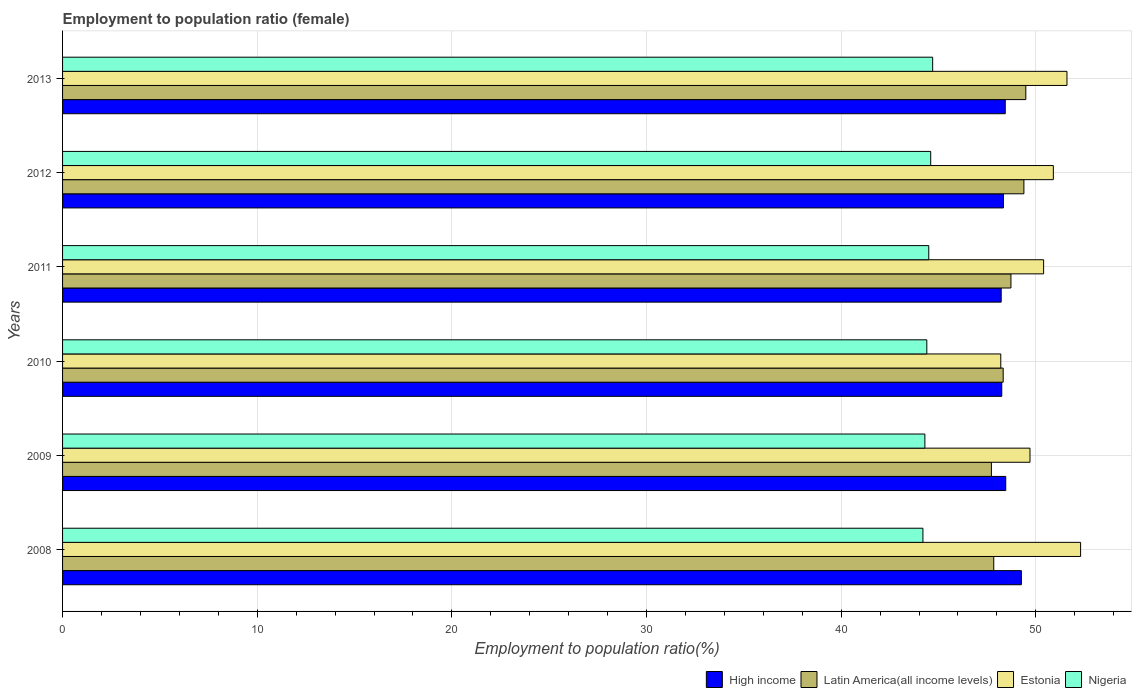How many different coloured bars are there?
Provide a succinct answer. 4. How many groups of bars are there?
Make the answer very short. 6. Are the number of bars per tick equal to the number of legend labels?
Give a very brief answer. Yes. Are the number of bars on each tick of the Y-axis equal?
Give a very brief answer. Yes. How many bars are there on the 3rd tick from the top?
Keep it short and to the point. 4. What is the label of the 2nd group of bars from the top?
Your response must be concise. 2012. What is the employment to population ratio in Latin America(all income levels) in 2008?
Your response must be concise. 47.84. Across all years, what is the maximum employment to population ratio in High income?
Your response must be concise. 49.26. Across all years, what is the minimum employment to population ratio in Latin America(all income levels)?
Provide a succinct answer. 47.72. In which year was the employment to population ratio in High income minimum?
Your response must be concise. 2011. What is the total employment to population ratio in Estonia in the graph?
Make the answer very short. 303.1. What is the difference between the employment to population ratio in High income in 2009 and that in 2012?
Ensure brevity in your answer.  0.12. What is the difference between the employment to population ratio in Nigeria in 2011 and the employment to population ratio in Estonia in 2008?
Ensure brevity in your answer.  -7.8. What is the average employment to population ratio in Nigeria per year?
Offer a terse response. 44.45. In the year 2009, what is the difference between the employment to population ratio in High income and employment to population ratio in Estonia?
Your response must be concise. -1.24. In how many years, is the employment to population ratio in Nigeria greater than 50 %?
Keep it short and to the point. 0. What is the ratio of the employment to population ratio in Estonia in 2008 to that in 2013?
Give a very brief answer. 1.01. Is the employment to population ratio in High income in 2011 less than that in 2013?
Ensure brevity in your answer.  Yes. Is the difference between the employment to population ratio in High income in 2010 and 2013 greater than the difference between the employment to population ratio in Estonia in 2010 and 2013?
Provide a short and direct response. Yes. What is the difference between the highest and the second highest employment to population ratio in High income?
Your response must be concise. 0.8. What is the difference between the highest and the lowest employment to population ratio in Latin America(all income levels)?
Your answer should be compact. 1.77. In how many years, is the employment to population ratio in High income greater than the average employment to population ratio in High income taken over all years?
Offer a very short reply. 1. Is the sum of the employment to population ratio in Latin America(all income levels) in 2009 and 2011 greater than the maximum employment to population ratio in Nigeria across all years?
Make the answer very short. Yes. Is it the case that in every year, the sum of the employment to population ratio in Latin America(all income levels) and employment to population ratio in Nigeria is greater than the sum of employment to population ratio in High income and employment to population ratio in Estonia?
Your answer should be compact. No. What does the 3rd bar from the top in 2010 represents?
Your answer should be compact. Latin America(all income levels). What does the 3rd bar from the bottom in 2009 represents?
Offer a terse response. Estonia. Is it the case that in every year, the sum of the employment to population ratio in Latin America(all income levels) and employment to population ratio in Estonia is greater than the employment to population ratio in High income?
Offer a very short reply. Yes. How many bars are there?
Provide a short and direct response. 24. How many years are there in the graph?
Offer a very short reply. 6. Are the values on the major ticks of X-axis written in scientific E-notation?
Offer a very short reply. No. What is the title of the graph?
Your answer should be compact. Employment to population ratio (female). Does "High income" appear as one of the legend labels in the graph?
Provide a short and direct response. Yes. What is the label or title of the X-axis?
Keep it short and to the point. Employment to population ratio(%). What is the label or title of the Y-axis?
Keep it short and to the point. Years. What is the Employment to population ratio(%) of High income in 2008?
Provide a short and direct response. 49.26. What is the Employment to population ratio(%) in Latin America(all income levels) in 2008?
Your answer should be very brief. 47.84. What is the Employment to population ratio(%) in Estonia in 2008?
Offer a very short reply. 52.3. What is the Employment to population ratio(%) in Nigeria in 2008?
Offer a very short reply. 44.2. What is the Employment to population ratio(%) of High income in 2009?
Offer a very short reply. 48.46. What is the Employment to population ratio(%) in Latin America(all income levels) in 2009?
Your answer should be compact. 47.72. What is the Employment to population ratio(%) of Estonia in 2009?
Your answer should be compact. 49.7. What is the Employment to population ratio(%) of Nigeria in 2009?
Provide a succinct answer. 44.3. What is the Employment to population ratio(%) in High income in 2010?
Keep it short and to the point. 48.25. What is the Employment to population ratio(%) in Latin America(all income levels) in 2010?
Provide a short and direct response. 48.32. What is the Employment to population ratio(%) of Estonia in 2010?
Provide a short and direct response. 48.2. What is the Employment to population ratio(%) in Nigeria in 2010?
Your answer should be very brief. 44.4. What is the Employment to population ratio(%) of High income in 2011?
Offer a terse response. 48.22. What is the Employment to population ratio(%) in Latin America(all income levels) in 2011?
Your answer should be very brief. 48.72. What is the Employment to population ratio(%) in Estonia in 2011?
Offer a very short reply. 50.4. What is the Employment to population ratio(%) in Nigeria in 2011?
Your answer should be very brief. 44.5. What is the Employment to population ratio(%) of High income in 2012?
Provide a short and direct response. 48.34. What is the Employment to population ratio(%) in Latin America(all income levels) in 2012?
Offer a terse response. 49.39. What is the Employment to population ratio(%) in Estonia in 2012?
Make the answer very short. 50.9. What is the Employment to population ratio(%) of Nigeria in 2012?
Give a very brief answer. 44.6. What is the Employment to population ratio(%) of High income in 2013?
Offer a very short reply. 48.43. What is the Employment to population ratio(%) of Latin America(all income levels) in 2013?
Offer a very short reply. 49.49. What is the Employment to population ratio(%) in Estonia in 2013?
Provide a succinct answer. 51.6. What is the Employment to population ratio(%) of Nigeria in 2013?
Ensure brevity in your answer.  44.7. Across all years, what is the maximum Employment to population ratio(%) in High income?
Keep it short and to the point. 49.26. Across all years, what is the maximum Employment to population ratio(%) of Latin America(all income levels)?
Ensure brevity in your answer.  49.49. Across all years, what is the maximum Employment to population ratio(%) of Estonia?
Offer a very short reply. 52.3. Across all years, what is the maximum Employment to population ratio(%) of Nigeria?
Your answer should be very brief. 44.7. Across all years, what is the minimum Employment to population ratio(%) of High income?
Keep it short and to the point. 48.22. Across all years, what is the minimum Employment to population ratio(%) in Latin America(all income levels)?
Give a very brief answer. 47.72. Across all years, what is the minimum Employment to population ratio(%) in Estonia?
Ensure brevity in your answer.  48.2. Across all years, what is the minimum Employment to population ratio(%) in Nigeria?
Your answer should be very brief. 44.2. What is the total Employment to population ratio(%) in High income in the graph?
Your answer should be compact. 290.95. What is the total Employment to population ratio(%) of Latin America(all income levels) in the graph?
Ensure brevity in your answer.  291.48. What is the total Employment to population ratio(%) in Estonia in the graph?
Make the answer very short. 303.1. What is the total Employment to population ratio(%) in Nigeria in the graph?
Your response must be concise. 266.7. What is the difference between the Employment to population ratio(%) in High income in 2008 and that in 2009?
Offer a terse response. 0.8. What is the difference between the Employment to population ratio(%) of Latin America(all income levels) in 2008 and that in 2009?
Offer a very short reply. 0.12. What is the difference between the Employment to population ratio(%) in Estonia in 2008 and that in 2009?
Ensure brevity in your answer.  2.6. What is the difference between the Employment to population ratio(%) in Nigeria in 2008 and that in 2009?
Offer a very short reply. -0.1. What is the difference between the Employment to population ratio(%) of Latin America(all income levels) in 2008 and that in 2010?
Provide a succinct answer. -0.48. What is the difference between the Employment to population ratio(%) of High income in 2008 and that in 2011?
Offer a very short reply. 1.04. What is the difference between the Employment to population ratio(%) in Latin America(all income levels) in 2008 and that in 2011?
Your answer should be very brief. -0.88. What is the difference between the Employment to population ratio(%) in High income in 2008 and that in 2012?
Provide a short and direct response. 0.92. What is the difference between the Employment to population ratio(%) of Latin America(all income levels) in 2008 and that in 2012?
Ensure brevity in your answer.  -1.55. What is the difference between the Employment to population ratio(%) of High income in 2008 and that in 2013?
Your answer should be compact. 0.83. What is the difference between the Employment to population ratio(%) in Latin America(all income levels) in 2008 and that in 2013?
Provide a short and direct response. -1.65. What is the difference between the Employment to population ratio(%) of High income in 2009 and that in 2010?
Provide a succinct answer. 0.2. What is the difference between the Employment to population ratio(%) of Latin America(all income levels) in 2009 and that in 2010?
Give a very brief answer. -0.61. What is the difference between the Employment to population ratio(%) of Estonia in 2009 and that in 2010?
Your response must be concise. 1.5. What is the difference between the Employment to population ratio(%) of Nigeria in 2009 and that in 2010?
Your answer should be very brief. -0.1. What is the difference between the Employment to population ratio(%) of High income in 2009 and that in 2011?
Give a very brief answer. 0.23. What is the difference between the Employment to population ratio(%) of Latin America(all income levels) in 2009 and that in 2011?
Give a very brief answer. -1. What is the difference between the Employment to population ratio(%) in Estonia in 2009 and that in 2011?
Ensure brevity in your answer.  -0.7. What is the difference between the Employment to population ratio(%) in High income in 2009 and that in 2012?
Offer a terse response. 0.12. What is the difference between the Employment to population ratio(%) of Latin America(all income levels) in 2009 and that in 2012?
Make the answer very short. -1.67. What is the difference between the Employment to population ratio(%) in Nigeria in 2009 and that in 2012?
Offer a very short reply. -0.3. What is the difference between the Employment to population ratio(%) of High income in 2009 and that in 2013?
Your answer should be compact. 0.03. What is the difference between the Employment to population ratio(%) of Latin America(all income levels) in 2009 and that in 2013?
Provide a succinct answer. -1.77. What is the difference between the Employment to population ratio(%) in Estonia in 2009 and that in 2013?
Provide a succinct answer. -1.9. What is the difference between the Employment to population ratio(%) in High income in 2010 and that in 2011?
Offer a very short reply. 0.03. What is the difference between the Employment to population ratio(%) in Latin America(all income levels) in 2010 and that in 2011?
Provide a short and direct response. -0.4. What is the difference between the Employment to population ratio(%) in Nigeria in 2010 and that in 2011?
Your answer should be very brief. -0.1. What is the difference between the Employment to population ratio(%) in High income in 2010 and that in 2012?
Your response must be concise. -0.09. What is the difference between the Employment to population ratio(%) in Latin America(all income levels) in 2010 and that in 2012?
Your response must be concise. -1.06. What is the difference between the Employment to population ratio(%) in Estonia in 2010 and that in 2012?
Your answer should be very brief. -2.7. What is the difference between the Employment to population ratio(%) of High income in 2010 and that in 2013?
Your answer should be compact. -0.18. What is the difference between the Employment to population ratio(%) of Latin America(all income levels) in 2010 and that in 2013?
Keep it short and to the point. -1.16. What is the difference between the Employment to population ratio(%) of Estonia in 2010 and that in 2013?
Provide a short and direct response. -3.4. What is the difference between the Employment to population ratio(%) of High income in 2011 and that in 2012?
Provide a succinct answer. -0.12. What is the difference between the Employment to population ratio(%) in Latin America(all income levels) in 2011 and that in 2012?
Make the answer very short. -0.67. What is the difference between the Employment to population ratio(%) in Estonia in 2011 and that in 2012?
Offer a very short reply. -0.5. What is the difference between the Employment to population ratio(%) in Nigeria in 2011 and that in 2012?
Provide a short and direct response. -0.1. What is the difference between the Employment to population ratio(%) of High income in 2011 and that in 2013?
Ensure brevity in your answer.  -0.21. What is the difference between the Employment to population ratio(%) in Latin America(all income levels) in 2011 and that in 2013?
Offer a very short reply. -0.76. What is the difference between the Employment to population ratio(%) in Estonia in 2011 and that in 2013?
Give a very brief answer. -1.2. What is the difference between the Employment to population ratio(%) in High income in 2012 and that in 2013?
Your answer should be very brief. -0.09. What is the difference between the Employment to population ratio(%) in Latin America(all income levels) in 2012 and that in 2013?
Your response must be concise. -0.1. What is the difference between the Employment to population ratio(%) in Estonia in 2012 and that in 2013?
Keep it short and to the point. -0.7. What is the difference between the Employment to population ratio(%) of High income in 2008 and the Employment to population ratio(%) of Latin America(all income levels) in 2009?
Keep it short and to the point. 1.54. What is the difference between the Employment to population ratio(%) in High income in 2008 and the Employment to population ratio(%) in Estonia in 2009?
Keep it short and to the point. -0.44. What is the difference between the Employment to population ratio(%) of High income in 2008 and the Employment to population ratio(%) of Nigeria in 2009?
Provide a short and direct response. 4.96. What is the difference between the Employment to population ratio(%) in Latin America(all income levels) in 2008 and the Employment to population ratio(%) in Estonia in 2009?
Make the answer very short. -1.86. What is the difference between the Employment to population ratio(%) of Latin America(all income levels) in 2008 and the Employment to population ratio(%) of Nigeria in 2009?
Offer a terse response. 3.54. What is the difference between the Employment to population ratio(%) of High income in 2008 and the Employment to population ratio(%) of Latin America(all income levels) in 2010?
Provide a succinct answer. 0.93. What is the difference between the Employment to population ratio(%) in High income in 2008 and the Employment to population ratio(%) in Estonia in 2010?
Provide a short and direct response. 1.06. What is the difference between the Employment to population ratio(%) of High income in 2008 and the Employment to population ratio(%) of Nigeria in 2010?
Your answer should be very brief. 4.86. What is the difference between the Employment to population ratio(%) of Latin America(all income levels) in 2008 and the Employment to population ratio(%) of Estonia in 2010?
Provide a succinct answer. -0.36. What is the difference between the Employment to population ratio(%) in Latin America(all income levels) in 2008 and the Employment to population ratio(%) in Nigeria in 2010?
Your response must be concise. 3.44. What is the difference between the Employment to population ratio(%) in Estonia in 2008 and the Employment to population ratio(%) in Nigeria in 2010?
Provide a short and direct response. 7.9. What is the difference between the Employment to population ratio(%) in High income in 2008 and the Employment to population ratio(%) in Latin America(all income levels) in 2011?
Keep it short and to the point. 0.54. What is the difference between the Employment to population ratio(%) of High income in 2008 and the Employment to population ratio(%) of Estonia in 2011?
Give a very brief answer. -1.14. What is the difference between the Employment to population ratio(%) of High income in 2008 and the Employment to population ratio(%) of Nigeria in 2011?
Your response must be concise. 4.76. What is the difference between the Employment to population ratio(%) in Latin America(all income levels) in 2008 and the Employment to population ratio(%) in Estonia in 2011?
Make the answer very short. -2.56. What is the difference between the Employment to population ratio(%) in Latin America(all income levels) in 2008 and the Employment to population ratio(%) in Nigeria in 2011?
Make the answer very short. 3.34. What is the difference between the Employment to population ratio(%) of High income in 2008 and the Employment to population ratio(%) of Latin America(all income levels) in 2012?
Ensure brevity in your answer.  -0.13. What is the difference between the Employment to population ratio(%) of High income in 2008 and the Employment to population ratio(%) of Estonia in 2012?
Ensure brevity in your answer.  -1.64. What is the difference between the Employment to population ratio(%) of High income in 2008 and the Employment to population ratio(%) of Nigeria in 2012?
Offer a terse response. 4.66. What is the difference between the Employment to population ratio(%) in Latin America(all income levels) in 2008 and the Employment to population ratio(%) in Estonia in 2012?
Keep it short and to the point. -3.06. What is the difference between the Employment to population ratio(%) of Latin America(all income levels) in 2008 and the Employment to population ratio(%) of Nigeria in 2012?
Offer a terse response. 3.24. What is the difference between the Employment to population ratio(%) in Estonia in 2008 and the Employment to population ratio(%) in Nigeria in 2012?
Ensure brevity in your answer.  7.7. What is the difference between the Employment to population ratio(%) in High income in 2008 and the Employment to population ratio(%) in Latin America(all income levels) in 2013?
Give a very brief answer. -0.23. What is the difference between the Employment to population ratio(%) in High income in 2008 and the Employment to population ratio(%) in Estonia in 2013?
Provide a succinct answer. -2.34. What is the difference between the Employment to population ratio(%) of High income in 2008 and the Employment to population ratio(%) of Nigeria in 2013?
Keep it short and to the point. 4.56. What is the difference between the Employment to population ratio(%) in Latin America(all income levels) in 2008 and the Employment to population ratio(%) in Estonia in 2013?
Ensure brevity in your answer.  -3.76. What is the difference between the Employment to population ratio(%) of Latin America(all income levels) in 2008 and the Employment to population ratio(%) of Nigeria in 2013?
Give a very brief answer. 3.14. What is the difference between the Employment to population ratio(%) of Estonia in 2008 and the Employment to population ratio(%) of Nigeria in 2013?
Keep it short and to the point. 7.6. What is the difference between the Employment to population ratio(%) in High income in 2009 and the Employment to population ratio(%) in Latin America(all income levels) in 2010?
Your response must be concise. 0.13. What is the difference between the Employment to population ratio(%) in High income in 2009 and the Employment to population ratio(%) in Estonia in 2010?
Your response must be concise. 0.26. What is the difference between the Employment to population ratio(%) of High income in 2009 and the Employment to population ratio(%) of Nigeria in 2010?
Offer a very short reply. 4.06. What is the difference between the Employment to population ratio(%) in Latin America(all income levels) in 2009 and the Employment to population ratio(%) in Estonia in 2010?
Provide a short and direct response. -0.48. What is the difference between the Employment to population ratio(%) in Latin America(all income levels) in 2009 and the Employment to population ratio(%) in Nigeria in 2010?
Ensure brevity in your answer.  3.32. What is the difference between the Employment to population ratio(%) in Estonia in 2009 and the Employment to population ratio(%) in Nigeria in 2010?
Your answer should be compact. 5.3. What is the difference between the Employment to population ratio(%) in High income in 2009 and the Employment to population ratio(%) in Latin America(all income levels) in 2011?
Ensure brevity in your answer.  -0.27. What is the difference between the Employment to population ratio(%) of High income in 2009 and the Employment to population ratio(%) of Estonia in 2011?
Your answer should be very brief. -1.94. What is the difference between the Employment to population ratio(%) in High income in 2009 and the Employment to population ratio(%) in Nigeria in 2011?
Provide a short and direct response. 3.96. What is the difference between the Employment to population ratio(%) of Latin America(all income levels) in 2009 and the Employment to population ratio(%) of Estonia in 2011?
Your answer should be compact. -2.68. What is the difference between the Employment to population ratio(%) of Latin America(all income levels) in 2009 and the Employment to population ratio(%) of Nigeria in 2011?
Your response must be concise. 3.22. What is the difference between the Employment to population ratio(%) in Estonia in 2009 and the Employment to population ratio(%) in Nigeria in 2011?
Your response must be concise. 5.2. What is the difference between the Employment to population ratio(%) of High income in 2009 and the Employment to population ratio(%) of Latin America(all income levels) in 2012?
Offer a terse response. -0.93. What is the difference between the Employment to population ratio(%) in High income in 2009 and the Employment to population ratio(%) in Estonia in 2012?
Offer a very short reply. -2.44. What is the difference between the Employment to population ratio(%) in High income in 2009 and the Employment to population ratio(%) in Nigeria in 2012?
Your response must be concise. 3.86. What is the difference between the Employment to population ratio(%) in Latin America(all income levels) in 2009 and the Employment to population ratio(%) in Estonia in 2012?
Keep it short and to the point. -3.18. What is the difference between the Employment to population ratio(%) of Latin America(all income levels) in 2009 and the Employment to population ratio(%) of Nigeria in 2012?
Your answer should be compact. 3.12. What is the difference between the Employment to population ratio(%) in Estonia in 2009 and the Employment to population ratio(%) in Nigeria in 2012?
Offer a very short reply. 5.1. What is the difference between the Employment to population ratio(%) of High income in 2009 and the Employment to population ratio(%) of Latin America(all income levels) in 2013?
Your answer should be compact. -1.03. What is the difference between the Employment to population ratio(%) of High income in 2009 and the Employment to population ratio(%) of Estonia in 2013?
Your answer should be very brief. -3.14. What is the difference between the Employment to population ratio(%) in High income in 2009 and the Employment to population ratio(%) in Nigeria in 2013?
Your response must be concise. 3.76. What is the difference between the Employment to population ratio(%) in Latin America(all income levels) in 2009 and the Employment to population ratio(%) in Estonia in 2013?
Your answer should be very brief. -3.88. What is the difference between the Employment to population ratio(%) in Latin America(all income levels) in 2009 and the Employment to population ratio(%) in Nigeria in 2013?
Provide a succinct answer. 3.02. What is the difference between the Employment to population ratio(%) of Estonia in 2009 and the Employment to population ratio(%) of Nigeria in 2013?
Your response must be concise. 5. What is the difference between the Employment to population ratio(%) in High income in 2010 and the Employment to population ratio(%) in Latin America(all income levels) in 2011?
Your answer should be very brief. -0.47. What is the difference between the Employment to population ratio(%) of High income in 2010 and the Employment to population ratio(%) of Estonia in 2011?
Your answer should be very brief. -2.15. What is the difference between the Employment to population ratio(%) of High income in 2010 and the Employment to population ratio(%) of Nigeria in 2011?
Make the answer very short. 3.75. What is the difference between the Employment to population ratio(%) in Latin America(all income levels) in 2010 and the Employment to population ratio(%) in Estonia in 2011?
Offer a terse response. -2.08. What is the difference between the Employment to population ratio(%) of Latin America(all income levels) in 2010 and the Employment to population ratio(%) of Nigeria in 2011?
Provide a succinct answer. 3.82. What is the difference between the Employment to population ratio(%) of High income in 2010 and the Employment to population ratio(%) of Latin America(all income levels) in 2012?
Make the answer very short. -1.14. What is the difference between the Employment to population ratio(%) of High income in 2010 and the Employment to population ratio(%) of Estonia in 2012?
Provide a short and direct response. -2.65. What is the difference between the Employment to population ratio(%) of High income in 2010 and the Employment to population ratio(%) of Nigeria in 2012?
Your answer should be compact. 3.65. What is the difference between the Employment to population ratio(%) in Latin America(all income levels) in 2010 and the Employment to population ratio(%) in Estonia in 2012?
Keep it short and to the point. -2.58. What is the difference between the Employment to population ratio(%) in Latin America(all income levels) in 2010 and the Employment to population ratio(%) in Nigeria in 2012?
Your answer should be very brief. 3.72. What is the difference between the Employment to population ratio(%) of Estonia in 2010 and the Employment to population ratio(%) of Nigeria in 2012?
Your answer should be compact. 3.6. What is the difference between the Employment to population ratio(%) in High income in 2010 and the Employment to population ratio(%) in Latin America(all income levels) in 2013?
Your response must be concise. -1.24. What is the difference between the Employment to population ratio(%) of High income in 2010 and the Employment to population ratio(%) of Estonia in 2013?
Your answer should be very brief. -3.35. What is the difference between the Employment to population ratio(%) in High income in 2010 and the Employment to population ratio(%) in Nigeria in 2013?
Offer a very short reply. 3.55. What is the difference between the Employment to population ratio(%) of Latin America(all income levels) in 2010 and the Employment to population ratio(%) of Estonia in 2013?
Keep it short and to the point. -3.28. What is the difference between the Employment to population ratio(%) of Latin America(all income levels) in 2010 and the Employment to population ratio(%) of Nigeria in 2013?
Make the answer very short. 3.62. What is the difference between the Employment to population ratio(%) of Estonia in 2010 and the Employment to population ratio(%) of Nigeria in 2013?
Offer a terse response. 3.5. What is the difference between the Employment to population ratio(%) of High income in 2011 and the Employment to population ratio(%) of Latin America(all income levels) in 2012?
Your answer should be very brief. -1.17. What is the difference between the Employment to population ratio(%) of High income in 2011 and the Employment to population ratio(%) of Estonia in 2012?
Offer a very short reply. -2.68. What is the difference between the Employment to population ratio(%) of High income in 2011 and the Employment to population ratio(%) of Nigeria in 2012?
Your answer should be very brief. 3.62. What is the difference between the Employment to population ratio(%) in Latin America(all income levels) in 2011 and the Employment to population ratio(%) in Estonia in 2012?
Make the answer very short. -2.18. What is the difference between the Employment to population ratio(%) in Latin America(all income levels) in 2011 and the Employment to population ratio(%) in Nigeria in 2012?
Give a very brief answer. 4.12. What is the difference between the Employment to population ratio(%) of High income in 2011 and the Employment to population ratio(%) of Latin America(all income levels) in 2013?
Make the answer very short. -1.27. What is the difference between the Employment to population ratio(%) in High income in 2011 and the Employment to population ratio(%) in Estonia in 2013?
Provide a succinct answer. -3.38. What is the difference between the Employment to population ratio(%) of High income in 2011 and the Employment to population ratio(%) of Nigeria in 2013?
Offer a terse response. 3.52. What is the difference between the Employment to population ratio(%) in Latin America(all income levels) in 2011 and the Employment to population ratio(%) in Estonia in 2013?
Make the answer very short. -2.88. What is the difference between the Employment to population ratio(%) of Latin America(all income levels) in 2011 and the Employment to population ratio(%) of Nigeria in 2013?
Provide a succinct answer. 4.02. What is the difference between the Employment to population ratio(%) of Estonia in 2011 and the Employment to population ratio(%) of Nigeria in 2013?
Your response must be concise. 5.7. What is the difference between the Employment to population ratio(%) of High income in 2012 and the Employment to population ratio(%) of Latin America(all income levels) in 2013?
Ensure brevity in your answer.  -1.15. What is the difference between the Employment to population ratio(%) of High income in 2012 and the Employment to population ratio(%) of Estonia in 2013?
Ensure brevity in your answer.  -3.26. What is the difference between the Employment to population ratio(%) of High income in 2012 and the Employment to population ratio(%) of Nigeria in 2013?
Make the answer very short. 3.64. What is the difference between the Employment to population ratio(%) in Latin America(all income levels) in 2012 and the Employment to population ratio(%) in Estonia in 2013?
Ensure brevity in your answer.  -2.21. What is the difference between the Employment to population ratio(%) of Latin America(all income levels) in 2012 and the Employment to population ratio(%) of Nigeria in 2013?
Keep it short and to the point. 4.69. What is the average Employment to population ratio(%) in High income per year?
Your answer should be very brief. 48.49. What is the average Employment to population ratio(%) in Latin America(all income levels) per year?
Your answer should be very brief. 48.58. What is the average Employment to population ratio(%) in Estonia per year?
Your answer should be very brief. 50.52. What is the average Employment to population ratio(%) in Nigeria per year?
Make the answer very short. 44.45. In the year 2008, what is the difference between the Employment to population ratio(%) in High income and Employment to population ratio(%) in Latin America(all income levels)?
Give a very brief answer. 1.42. In the year 2008, what is the difference between the Employment to population ratio(%) of High income and Employment to population ratio(%) of Estonia?
Offer a very short reply. -3.04. In the year 2008, what is the difference between the Employment to population ratio(%) in High income and Employment to population ratio(%) in Nigeria?
Ensure brevity in your answer.  5.06. In the year 2008, what is the difference between the Employment to population ratio(%) of Latin America(all income levels) and Employment to population ratio(%) of Estonia?
Provide a short and direct response. -4.46. In the year 2008, what is the difference between the Employment to population ratio(%) of Latin America(all income levels) and Employment to population ratio(%) of Nigeria?
Your response must be concise. 3.64. In the year 2009, what is the difference between the Employment to population ratio(%) in High income and Employment to population ratio(%) in Latin America(all income levels)?
Provide a succinct answer. 0.74. In the year 2009, what is the difference between the Employment to population ratio(%) in High income and Employment to population ratio(%) in Estonia?
Give a very brief answer. -1.24. In the year 2009, what is the difference between the Employment to population ratio(%) of High income and Employment to population ratio(%) of Nigeria?
Ensure brevity in your answer.  4.16. In the year 2009, what is the difference between the Employment to population ratio(%) in Latin America(all income levels) and Employment to population ratio(%) in Estonia?
Make the answer very short. -1.98. In the year 2009, what is the difference between the Employment to population ratio(%) of Latin America(all income levels) and Employment to population ratio(%) of Nigeria?
Your response must be concise. 3.42. In the year 2009, what is the difference between the Employment to population ratio(%) in Estonia and Employment to population ratio(%) in Nigeria?
Provide a succinct answer. 5.4. In the year 2010, what is the difference between the Employment to population ratio(%) of High income and Employment to population ratio(%) of Latin America(all income levels)?
Your answer should be very brief. -0.07. In the year 2010, what is the difference between the Employment to population ratio(%) in High income and Employment to population ratio(%) in Estonia?
Make the answer very short. 0.05. In the year 2010, what is the difference between the Employment to population ratio(%) in High income and Employment to population ratio(%) in Nigeria?
Offer a terse response. 3.85. In the year 2010, what is the difference between the Employment to population ratio(%) of Latin America(all income levels) and Employment to population ratio(%) of Estonia?
Give a very brief answer. 0.12. In the year 2010, what is the difference between the Employment to population ratio(%) in Latin America(all income levels) and Employment to population ratio(%) in Nigeria?
Ensure brevity in your answer.  3.92. In the year 2010, what is the difference between the Employment to population ratio(%) in Estonia and Employment to population ratio(%) in Nigeria?
Your answer should be compact. 3.8. In the year 2011, what is the difference between the Employment to population ratio(%) in High income and Employment to population ratio(%) in Latin America(all income levels)?
Your answer should be very brief. -0.5. In the year 2011, what is the difference between the Employment to population ratio(%) of High income and Employment to population ratio(%) of Estonia?
Your answer should be compact. -2.18. In the year 2011, what is the difference between the Employment to population ratio(%) in High income and Employment to population ratio(%) in Nigeria?
Your answer should be compact. 3.72. In the year 2011, what is the difference between the Employment to population ratio(%) in Latin America(all income levels) and Employment to population ratio(%) in Estonia?
Your answer should be compact. -1.68. In the year 2011, what is the difference between the Employment to population ratio(%) of Latin America(all income levels) and Employment to population ratio(%) of Nigeria?
Make the answer very short. 4.22. In the year 2011, what is the difference between the Employment to population ratio(%) of Estonia and Employment to population ratio(%) of Nigeria?
Your answer should be compact. 5.9. In the year 2012, what is the difference between the Employment to population ratio(%) in High income and Employment to population ratio(%) in Latin America(all income levels)?
Your answer should be very brief. -1.05. In the year 2012, what is the difference between the Employment to population ratio(%) of High income and Employment to population ratio(%) of Estonia?
Ensure brevity in your answer.  -2.56. In the year 2012, what is the difference between the Employment to population ratio(%) in High income and Employment to population ratio(%) in Nigeria?
Your answer should be very brief. 3.74. In the year 2012, what is the difference between the Employment to population ratio(%) in Latin America(all income levels) and Employment to population ratio(%) in Estonia?
Provide a short and direct response. -1.51. In the year 2012, what is the difference between the Employment to population ratio(%) of Latin America(all income levels) and Employment to population ratio(%) of Nigeria?
Keep it short and to the point. 4.79. In the year 2012, what is the difference between the Employment to population ratio(%) of Estonia and Employment to population ratio(%) of Nigeria?
Give a very brief answer. 6.3. In the year 2013, what is the difference between the Employment to population ratio(%) of High income and Employment to population ratio(%) of Latin America(all income levels)?
Ensure brevity in your answer.  -1.06. In the year 2013, what is the difference between the Employment to population ratio(%) of High income and Employment to population ratio(%) of Estonia?
Provide a short and direct response. -3.17. In the year 2013, what is the difference between the Employment to population ratio(%) of High income and Employment to population ratio(%) of Nigeria?
Offer a very short reply. 3.73. In the year 2013, what is the difference between the Employment to population ratio(%) of Latin America(all income levels) and Employment to population ratio(%) of Estonia?
Give a very brief answer. -2.11. In the year 2013, what is the difference between the Employment to population ratio(%) in Latin America(all income levels) and Employment to population ratio(%) in Nigeria?
Give a very brief answer. 4.79. What is the ratio of the Employment to population ratio(%) of High income in 2008 to that in 2009?
Your response must be concise. 1.02. What is the ratio of the Employment to population ratio(%) in Latin America(all income levels) in 2008 to that in 2009?
Your answer should be compact. 1. What is the ratio of the Employment to population ratio(%) in Estonia in 2008 to that in 2009?
Your answer should be compact. 1.05. What is the ratio of the Employment to population ratio(%) in High income in 2008 to that in 2010?
Your response must be concise. 1.02. What is the ratio of the Employment to population ratio(%) of Latin America(all income levels) in 2008 to that in 2010?
Your answer should be compact. 0.99. What is the ratio of the Employment to population ratio(%) of Estonia in 2008 to that in 2010?
Provide a succinct answer. 1.09. What is the ratio of the Employment to population ratio(%) of Nigeria in 2008 to that in 2010?
Your response must be concise. 1. What is the ratio of the Employment to population ratio(%) of High income in 2008 to that in 2011?
Provide a short and direct response. 1.02. What is the ratio of the Employment to population ratio(%) in Latin America(all income levels) in 2008 to that in 2011?
Provide a succinct answer. 0.98. What is the ratio of the Employment to population ratio(%) of Estonia in 2008 to that in 2011?
Provide a short and direct response. 1.04. What is the ratio of the Employment to population ratio(%) in High income in 2008 to that in 2012?
Offer a terse response. 1.02. What is the ratio of the Employment to population ratio(%) of Latin America(all income levels) in 2008 to that in 2012?
Your answer should be very brief. 0.97. What is the ratio of the Employment to population ratio(%) of Estonia in 2008 to that in 2012?
Make the answer very short. 1.03. What is the ratio of the Employment to population ratio(%) of Nigeria in 2008 to that in 2012?
Provide a short and direct response. 0.99. What is the ratio of the Employment to population ratio(%) of High income in 2008 to that in 2013?
Make the answer very short. 1.02. What is the ratio of the Employment to population ratio(%) of Latin America(all income levels) in 2008 to that in 2013?
Offer a terse response. 0.97. What is the ratio of the Employment to population ratio(%) in Estonia in 2008 to that in 2013?
Provide a succinct answer. 1.01. What is the ratio of the Employment to population ratio(%) in Nigeria in 2008 to that in 2013?
Ensure brevity in your answer.  0.99. What is the ratio of the Employment to population ratio(%) in High income in 2009 to that in 2010?
Your response must be concise. 1. What is the ratio of the Employment to population ratio(%) of Latin America(all income levels) in 2009 to that in 2010?
Ensure brevity in your answer.  0.99. What is the ratio of the Employment to population ratio(%) of Estonia in 2009 to that in 2010?
Offer a terse response. 1.03. What is the ratio of the Employment to population ratio(%) in Nigeria in 2009 to that in 2010?
Give a very brief answer. 1. What is the ratio of the Employment to population ratio(%) in High income in 2009 to that in 2011?
Offer a very short reply. 1. What is the ratio of the Employment to population ratio(%) in Latin America(all income levels) in 2009 to that in 2011?
Give a very brief answer. 0.98. What is the ratio of the Employment to population ratio(%) in Estonia in 2009 to that in 2011?
Keep it short and to the point. 0.99. What is the ratio of the Employment to population ratio(%) of Nigeria in 2009 to that in 2011?
Ensure brevity in your answer.  1. What is the ratio of the Employment to population ratio(%) of High income in 2009 to that in 2012?
Ensure brevity in your answer.  1. What is the ratio of the Employment to population ratio(%) of Latin America(all income levels) in 2009 to that in 2012?
Provide a short and direct response. 0.97. What is the ratio of the Employment to population ratio(%) in Estonia in 2009 to that in 2012?
Provide a short and direct response. 0.98. What is the ratio of the Employment to population ratio(%) of High income in 2009 to that in 2013?
Make the answer very short. 1. What is the ratio of the Employment to population ratio(%) in Latin America(all income levels) in 2009 to that in 2013?
Provide a succinct answer. 0.96. What is the ratio of the Employment to population ratio(%) of Estonia in 2009 to that in 2013?
Make the answer very short. 0.96. What is the ratio of the Employment to population ratio(%) of Nigeria in 2009 to that in 2013?
Your response must be concise. 0.99. What is the ratio of the Employment to population ratio(%) in Estonia in 2010 to that in 2011?
Give a very brief answer. 0.96. What is the ratio of the Employment to population ratio(%) of Nigeria in 2010 to that in 2011?
Provide a short and direct response. 1. What is the ratio of the Employment to population ratio(%) of Latin America(all income levels) in 2010 to that in 2012?
Give a very brief answer. 0.98. What is the ratio of the Employment to population ratio(%) of Estonia in 2010 to that in 2012?
Your answer should be compact. 0.95. What is the ratio of the Employment to population ratio(%) of High income in 2010 to that in 2013?
Make the answer very short. 1. What is the ratio of the Employment to population ratio(%) in Latin America(all income levels) in 2010 to that in 2013?
Offer a terse response. 0.98. What is the ratio of the Employment to population ratio(%) in Estonia in 2010 to that in 2013?
Ensure brevity in your answer.  0.93. What is the ratio of the Employment to population ratio(%) of High income in 2011 to that in 2012?
Provide a succinct answer. 1. What is the ratio of the Employment to population ratio(%) of Latin America(all income levels) in 2011 to that in 2012?
Offer a very short reply. 0.99. What is the ratio of the Employment to population ratio(%) of Estonia in 2011 to that in 2012?
Your answer should be very brief. 0.99. What is the ratio of the Employment to population ratio(%) in Nigeria in 2011 to that in 2012?
Your response must be concise. 1. What is the ratio of the Employment to population ratio(%) of Latin America(all income levels) in 2011 to that in 2013?
Your response must be concise. 0.98. What is the ratio of the Employment to population ratio(%) of Estonia in 2011 to that in 2013?
Provide a succinct answer. 0.98. What is the ratio of the Employment to population ratio(%) in Estonia in 2012 to that in 2013?
Give a very brief answer. 0.99. What is the difference between the highest and the second highest Employment to population ratio(%) of High income?
Ensure brevity in your answer.  0.8. What is the difference between the highest and the second highest Employment to population ratio(%) of Latin America(all income levels)?
Your response must be concise. 0.1. What is the difference between the highest and the lowest Employment to population ratio(%) in High income?
Your answer should be very brief. 1.04. What is the difference between the highest and the lowest Employment to population ratio(%) of Latin America(all income levels)?
Offer a very short reply. 1.77. 